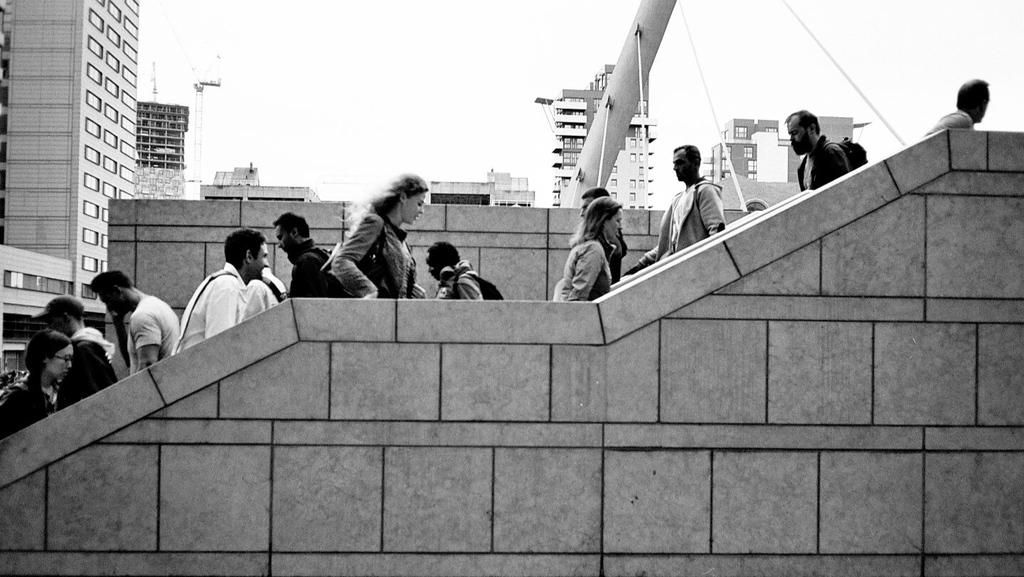What are the people in the image doing? There are many people walking on the stairs in the image. What is located in the front of the image? There is a wall in the front of the image. What can be seen in the background of the image? There are buildings and skyscrapers in the background of the image. What is visible at the top of the image? The sky is visible at the top of the image. How much wool can be seen on the people walking on the stairs in the image? There is no wool visible on the people walking on the stairs in the image. What type of sign is present in the image? There is no sign present in the image. 